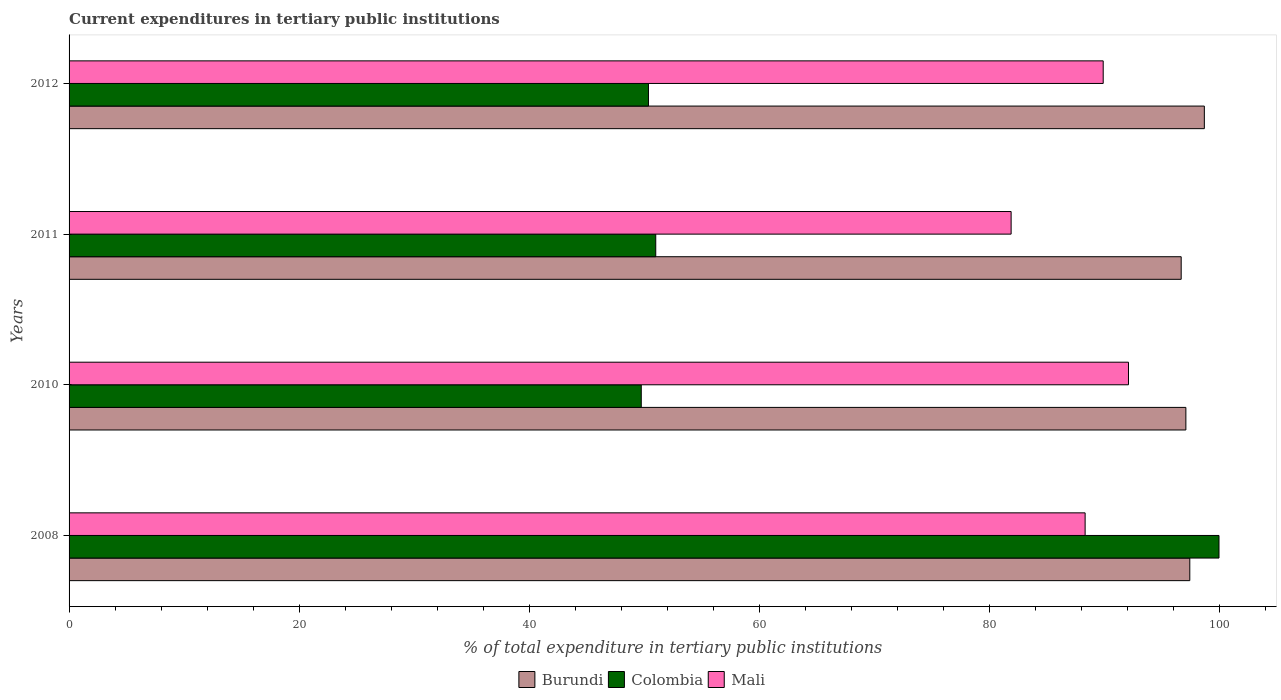How many different coloured bars are there?
Give a very brief answer. 3. Are the number of bars per tick equal to the number of legend labels?
Your answer should be very brief. Yes. What is the current expenditures in tertiary public institutions in Burundi in 2011?
Provide a short and direct response. 96.71. Across all years, what is the maximum current expenditures in tertiary public institutions in Burundi?
Ensure brevity in your answer.  98.73. Across all years, what is the minimum current expenditures in tertiary public institutions in Colombia?
Give a very brief answer. 49.76. In which year was the current expenditures in tertiary public institutions in Mali maximum?
Your response must be concise. 2010. In which year was the current expenditures in tertiary public institutions in Mali minimum?
Ensure brevity in your answer.  2011. What is the total current expenditures in tertiary public institutions in Mali in the graph?
Your answer should be compact. 352.34. What is the difference between the current expenditures in tertiary public institutions in Colombia in 2008 and that in 2011?
Your answer should be compact. 48.98. What is the difference between the current expenditures in tertiary public institutions in Mali in 2010 and the current expenditures in tertiary public institutions in Colombia in 2008?
Ensure brevity in your answer.  -7.87. What is the average current expenditures in tertiary public institutions in Mali per year?
Your answer should be very brief. 88.09. In the year 2011, what is the difference between the current expenditures in tertiary public institutions in Mali and current expenditures in tertiary public institutions in Burundi?
Offer a terse response. -14.79. What is the ratio of the current expenditures in tertiary public institutions in Burundi in 2008 to that in 2012?
Ensure brevity in your answer.  0.99. Is the current expenditures in tertiary public institutions in Burundi in 2008 less than that in 2010?
Provide a short and direct response. No. Is the difference between the current expenditures in tertiary public institutions in Mali in 2008 and 2012 greater than the difference between the current expenditures in tertiary public institutions in Burundi in 2008 and 2012?
Offer a very short reply. No. What is the difference between the highest and the second highest current expenditures in tertiary public institutions in Colombia?
Ensure brevity in your answer.  48.98. What is the difference between the highest and the lowest current expenditures in tertiary public institutions in Colombia?
Provide a short and direct response. 50.24. Is the sum of the current expenditures in tertiary public institutions in Mali in 2008 and 2012 greater than the maximum current expenditures in tertiary public institutions in Burundi across all years?
Offer a very short reply. Yes. What does the 2nd bar from the bottom in 2011 represents?
Offer a very short reply. Colombia. How many bars are there?
Keep it short and to the point. 12. How many years are there in the graph?
Ensure brevity in your answer.  4. Where does the legend appear in the graph?
Give a very brief answer. Bottom center. What is the title of the graph?
Give a very brief answer. Current expenditures in tertiary public institutions. What is the label or title of the X-axis?
Give a very brief answer. % of total expenditure in tertiary public institutions. What is the % of total expenditure in tertiary public institutions of Burundi in 2008?
Your answer should be compact. 97.46. What is the % of total expenditure in tertiary public institutions in Mali in 2008?
Offer a very short reply. 88.36. What is the % of total expenditure in tertiary public institutions in Burundi in 2010?
Offer a terse response. 97.12. What is the % of total expenditure in tertiary public institutions of Colombia in 2010?
Ensure brevity in your answer.  49.76. What is the % of total expenditure in tertiary public institutions of Mali in 2010?
Keep it short and to the point. 92.13. What is the % of total expenditure in tertiary public institutions of Burundi in 2011?
Your response must be concise. 96.71. What is the % of total expenditure in tertiary public institutions of Colombia in 2011?
Your answer should be very brief. 51.02. What is the % of total expenditure in tertiary public institutions in Mali in 2011?
Provide a succinct answer. 81.92. What is the % of total expenditure in tertiary public institutions of Burundi in 2012?
Provide a succinct answer. 98.73. What is the % of total expenditure in tertiary public institutions in Colombia in 2012?
Give a very brief answer. 50.39. What is the % of total expenditure in tertiary public institutions in Mali in 2012?
Your response must be concise. 89.93. Across all years, what is the maximum % of total expenditure in tertiary public institutions of Burundi?
Keep it short and to the point. 98.73. Across all years, what is the maximum % of total expenditure in tertiary public institutions of Mali?
Your response must be concise. 92.13. Across all years, what is the minimum % of total expenditure in tertiary public institutions in Burundi?
Ensure brevity in your answer.  96.71. Across all years, what is the minimum % of total expenditure in tertiary public institutions of Colombia?
Keep it short and to the point. 49.76. Across all years, what is the minimum % of total expenditure in tertiary public institutions in Mali?
Offer a very short reply. 81.92. What is the total % of total expenditure in tertiary public institutions in Burundi in the graph?
Ensure brevity in your answer.  390.02. What is the total % of total expenditure in tertiary public institutions of Colombia in the graph?
Your answer should be compact. 251.16. What is the total % of total expenditure in tertiary public institutions in Mali in the graph?
Your response must be concise. 352.34. What is the difference between the % of total expenditure in tertiary public institutions of Burundi in 2008 and that in 2010?
Ensure brevity in your answer.  0.34. What is the difference between the % of total expenditure in tertiary public institutions of Colombia in 2008 and that in 2010?
Offer a terse response. 50.24. What is the difference between the % of total expenditure in tertiary public institutions of Mali in 2008 and that in 2010?
Give a very brief answer. -3.77. What is the difference between the % of total expenditure in tertiary public institutions of Burundi in 2008 and that in 2011?
Make the answer very short. 0.75. What is the difference between the % of total expenditure in tertiary public institutions in Colombia in 2008 and that in 2011?
Your response must be concise. 48.98. What is the difference between the % of total expenditure in tertiary public institutions of Mali in 2008 and that in 2011?
Provide a short and direct response. 6.43. What is the difference between the % of total expenditure in tertiary public institutions of Burundi in 2008 and that in 2012?
Give a very brief answer. -1.27. What is the difference between the % of total expenditure in tertiary public institutions in Colombia in 2008 and that in 2012?
Ensure brevity in your answer.  49.61. What is the difference between the % of total expenditure in tertiary public institutions of Mali in 2008 and that in 2012?
Ensure brevity in your answer.  -1.57. What is the difference between the % of total expenditure in tertiary public institutions of Burundi in 2010 and that in 2011?
Provide a short and direct response. 0.41. What is the difference between the % of total expenditure in tertiary public institutions of Colombia in 2010 and that in 2011?
Your answer should be very brief. -1.26. What is the difference between the % of total expenditure in tertiary public institutions in Mali in 2010 and that in 2011?
Offer a terse response. 10.21. What is the difference between the % of total expenditure in tertiary public institutions of Burundi in 2010 and that in 2012?
Your answer should be very brief. -1.61. What is the difference between the % of total expenditure in tertiary public institutions in Colombia in 2010 and that in 2012?
Provide a succinct answer. -0.63. What is the difference between the % of total expenditure in tertiary public institutions in Mali in 2010 and that in 2012?
Make the answer very short. 2.2. What is the difference between the % of total expenditure in tertiary public institutions in Burundi in 2011 and that in 2012?
Ensure brevity in your answer.  -2.01. What is the difference between the % of total expenditure in tertiary public institutions in Colombia in 2011 and that in 2012?
Offer a very short reply. 0.63. What is the difference between the % of total expenditure in tertiary public institutions in Mali in 2011 and that in 2012?
Your response must be concise. -8.01. What is the difference between the % of total expenditure in tertiary public institutions of Burundi in 2008 and the % of total expenditure in tertiary public institutions of Colombia in 2010?
Offer a very short reply. 47.7. What is the difference between the % of total expenditure in tertiary public institutions of Burundi in 2008 and the % of total expenditure in tertiary public institutions of Mali in 2010?
Offer a terse response. 5.33. What is the difference between the % of total expenditure in tertiary public institutions of Colombia in 2008 and the % of total expenditure in tertiary public institutions of Mali in 2010?
Keep it short and to the point. 7.87. What is the difference between the % of total expenditure in tertiary public institutions in Burundi in 2008 and the % of total expenditure in tertiary public institutions in Colombia in 2011?
Your answer should be very brief. 46.44. What is the difference between the % of total expenditure in tertiary public institutions in Burundi in 2008 and the % of total expenditure in tertiary public institutions in Mali in 2011?
Offer a terse response. 15.54. What is the difference between the % of total expenditure in tertiary public institutions in Colombia in 2008 and the % of total expenditure in tertiary public institutions in Mali in 2011?
Offer a terse response. 18.08. What is the difference between the % of total expenditure in tertiary public institutions of Burundi in 2008 and the % of total expenditure in tertiary public institutions of Colombia in 2012?
Keep it short and to the point. 47.07. What is the difference between the % of total expenditure in tertiary public institutions of Burundi in 2008 and the % of total expenditure in tertiary public institutions of Mali in 2012?
Give a very brief answer. 7.53. What is the difference between the % of total expenditure in tertiary public institutions of Colombia in 2008 and the % of total expenditure in tertiary public institutions of Mali in 2012?
Your answer should be very brief. 10.07. What is the difference between the % of total expenditure in tertiary public institutions in Burundi in 2010 and the % of total expenditure in tertiary public institutions in Colombia in 2011?
Offer a terse response. 46.1. What is the difference between the % of total expenditure in tertiary public institutions in Burundi in 2010 and the % of total expenditure in tertiary public institutions in Mali in 2011?
Keep it short and to the point. 15.2. What is the difference between the % of total expenditure in tertiary public institutions of Colombia in 2010 and the % of total expenditure in tertiary public institutions of Mali in 2011?
Your answer should be very brief. -32.16. What is the difference between the % of total expenditure in tertiary public institutions in Burundi in 2010 and the % of total expenditure in tertiary public institutions in Colombia in 2012?
Make the answer very short. 46.73. What is the difference between the % of total expenditure in tertiary public institutions in Burundi in 2010 and the % of total expenditure in tertiary public institutions in Mali in 2012?
Offer a very short reply. 7.19. What is the difference between the % of total expenditure in tertiary public institutions of Colombia in 2010 and the % of total expenditure in tertiary public institutions of Mali in 2012?
Give a very brief answer. -40.17. What is the difference between the % of total expenditure in tertiary public institutions of Burundi in 2011 and the % of total expenditure in tertiary public institutions of Colombia in 2012?
Provide a succinct answer. 46.33. What is the difference between the % of total expenditure in tertiary public institutions of Burundi in 2011 and the % of total expenditure in tertiary public institutions of Mali in 2012?
Keep it short and to the point. 6.78. What is the difference between the % of total expenditure in tertiary public institutions of Colombia in 2011 and the % of total expenditure in tertiary public institutions of Mali in 2012?
Make the answer very short. -38.91. What is the average % of total expenditure in tertiary public institutions of Burundi per year?
Offer a terse response. 97.5. What is the average % of total expenditure in tertiary public institutions of Colombia per year?
Provide a short and direct response. 62.79. What is the average % of total expenditure in tertiary public institutions of Mali per year?
Ensure brevity in your answer.  88.09. In the year 2008, what is the difference between the % of total expenditure in tertiary public institutions in Burundi and % of total expenditure in tertiary public institutions in Colombia?
Offer a terse response. -2.54. In the year 2008, what is the difference between the % of total expenditure in tertiary public institutions of Burundi and % of total expenditure in tertiary public institutions of Mali?
Offer a terse response. 9.1. In the year 2008, what is the difference between the % of total expenditure in tertiary public institutions in Colombia and % of total expenditure in tertiary public institutions in Mali?
Make the answer very short. 11.64. In the year 2010, what is the difference between the % of total expenditure in tertiary public institutions in Burundi and % of total expenditure in tertiary public institutions in Colombia?
Offer a terse response. 47.36. In the year 2010, what is the difference between the % of total expenditure in tertiary public institutions of Burundi and % of total expenditure in tertiary public institutions of Mali?
Provide a short and direct response. 4.99. In the year 2010, what is the difference between the % of total expenditure in tertiary public institutions in Colombia and % of total expenditure in tertiary public institutions in Mali?
Your answer should be very brief. -42.37. In the year 2011, what is the difference between the % of total expenditure in tertiary public institutions of Burundi and % of total expenditure in tertiary public institutions of Colombia?
Provide a succinct answer. 45.69. In the year 2011, what is the difference between the % of total expenditure in tertiary public institutions of Burundi and % of total expenditure in tertiary public institutions of Mali?
Give a very brief answer. 14.79. In the year 2011, what is the difference between the % of total expenditure in tertiary public institutions of Colombia and % of total expenditure in tertiary public institutions of Mali?
Provide a short and direct response. -30.9. In the year 2012, what is the difference between the % of total expenditure in tertiary public institutions in Burundi and % of total expenditure in tertiary public institutions in Colombia?
Give a very brief answer. 48.34. In the year 2012, what is the difference between the % of total expenditure in tertiary public institutions of Burundi and % of total expenditure in tertiary public institutions of Mali?
Offer a very short reply. 8.8. In the year 2012, what is the difference between the % of total expenditure in tertiary public institutions in Colombia and % of total expenditure in tertiary public institutions in Mali?
Make the answer very short. -39.54. What is the ratio of the % of total expenditure in tertiary public institutions of Burundi in 2008 to that in 2010?
Keep it short and to the point. 1. What is the ratio of the % of total expenditure in tertiary public institutions in Colombia in 2008 to that in 2010?
Provide a short and direct response. 2.01. What is the ratio of the % of total expenditure in tertiary public institutions of Mali in 2008 to that in 2010?
Give a very brief answer. 0.96. What is the ratio of the % of total expenditure in tertiary public institutions of Burundi in 2008 to that in 2011?
Make the answer very short. 1.01. What is the ratio of the % of total expenditure in tertiary public institutions in Colombia in 2008 to that in 2011?
Offer a very short reply. 1.96. What is the ratio of the % of total expenditure in tertiary public institutions of Mali in 2008 to that in 2011?
Ensure brevity in your answer.  1.08. What is the ratio of the % of total expenditure in tertiary public institutions of Burundi in 2008 to that in 2012?
Offer a very short reply. 0.99. What is the ratio of the % of total expenditure in tertiary public institutions of Colombia in 2008 to that in 2012?
Provide a short and direct response. 1.98. What is the ratio of the % of total expenditure in tertiary public institutions in Mali in 2008 to that in 2012?
Your answer should be compact. 0.98. What is the ratio of the % of total expenditure in tertiary public institutions in Burundi in 2010 to that in 2011?
Your answer should be compact. 1. What is the ratio of the % of total expenditure in tertiary public institutions of Colombia in 2010 to that in 2011?
Your answer should be compact. 0.98. What is the ratio of the % of total expenditure in tertiary public institutions in Mali in 2010 to that in 2011?
Offer a very short reply. 1.12. What is the ratio of the % of total expenditure in tertiary public institutions of Burundi in 2010 to that in 2012?
Your response must be concise. 0.98. What is the ratio of the % of total expenditure in tertiary public institutions in Colombia in 2010 to that in 2012?
Ensure brevity in your answer.  0.99. What is the ratio of the % of total expenditure in tertiary public institutions in Mali in 2010 to that in 2012?
Your response must be concise. 1.02. What is the ratio of the % of total expenditure in tertiary public institutions of Burundi in 2011 to that in 2012?
Offer a terse response. 0.98. What is the ratio of the % of total expenditure in tertiary public institutions in Colombia in 2011 to that in 2012?
Keep it short and to the point. 1.01. What is the ratio of the % of total expenditure in tertiary public institutions of Mali in 2011 to that in 2012?
Provide a succinct answer. 0.91. What is the difference between the highest and the second highest % of total expenditure in tertiary public institutions in Burundi?
Your answer should be compact. 1.27. What is the difference between the highest and the second highest % of total expenditure in tertiary public institutions of Colombia?
Your answer should be very brief. 48.98. What is the difference between the highest and the second highest % of total expenditure in tertiary public institutions in Mali?
Give a very brief answer. 2.2. What is the difference between the highest and the lowest % of total expenditure in tertiary public institutions of Burundi?
Provide a short and direct response. 2.01. What is the difference between the highest and the lowest % of total expenditure in tertiary public institutions of Colombia?
Provide a short and direct response. 50.24. What is the difference between the highest and the lowest % of total expenditure in tertiary public institutions in Mali?
Make the answer very short. 10.21. 